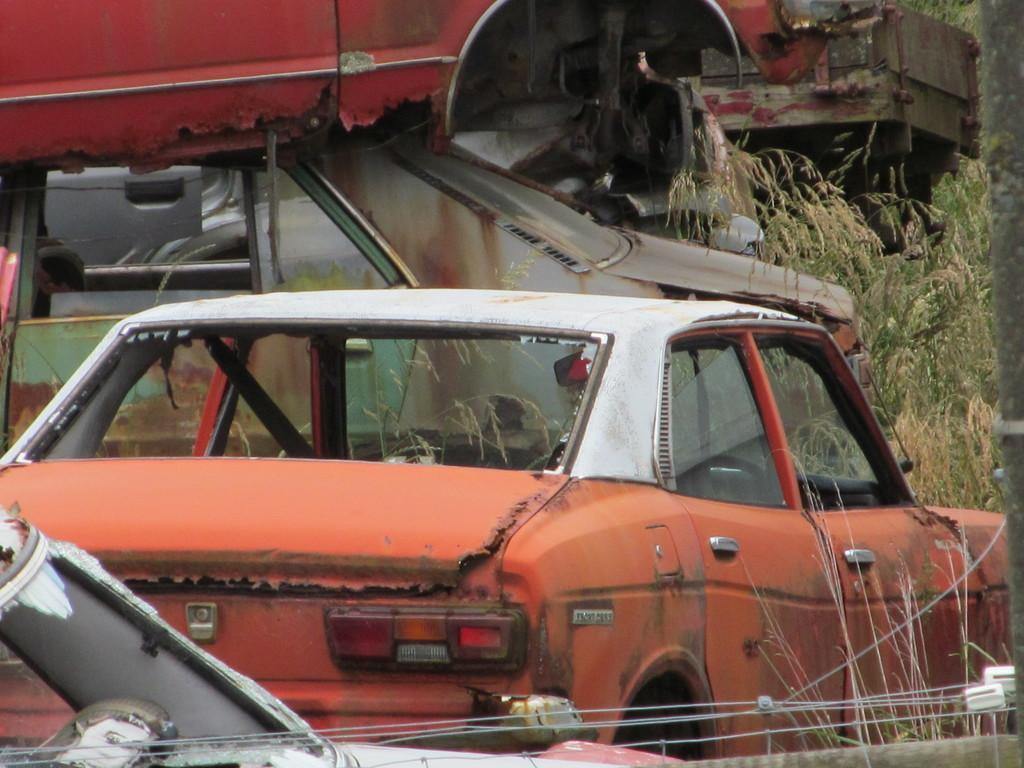In one or two sentences, can you explain what this image depicts? In this image we can see there are some vehicles, grass and wires. 